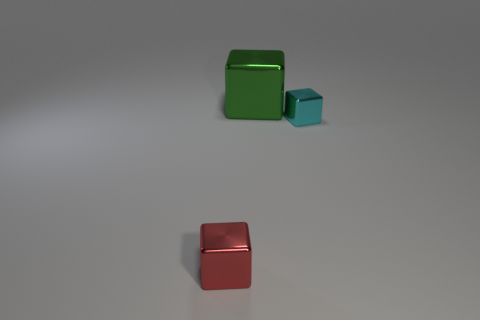What material is the thing that is right of the red shiny object and left of the cyan shiny block?
Your answer should be compact. Metal. There is another tiny shiny object that is the same shape as the cyan thing; what is its color?
Offer a very short reply. Red. There is a large metal block behind the tiny red block; is there a green metallic cube on the left side of it?
Provide a succinct answer. No. What size is the green thing?
Offer a very short reply. Large. What is the shape of the metallic thing that is both in front of the big green metal block and right of the red object?
Make the answer very short. Cube. What number of blue objects are either large blocks or small metal blocks?
Make the answer very short. 0. There is a block on the left side of the big green shiny thing; is its size the same as the block that is behind the cyan metallic thing?
Provide a succinct answer. No. What number of objects are red metal blocks or green shiny blocks?
Offer a very short reply. 2. Are there any other green things of the same shape as the large green thing?
Provide a succinct answer. No. Is the number of red shiny balls less than the number of tiny cyan cubes?
Offer a terse response. Yes. 